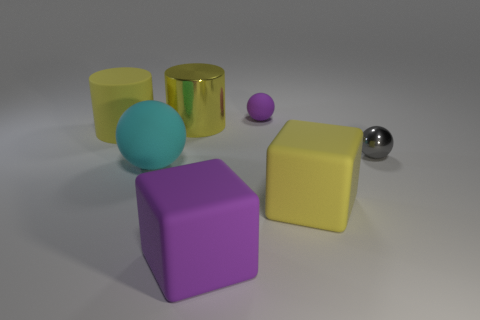Are there more small balls than large cyan cubes?
Your response must be concise. Yes. There is a large yellow matte thing that is behind the yellow cube; is it the same shape as the large yellow metallic thing?
Your answer should be very brief. Yes. Is the number of tiny gray balls less than the number of big blue things?
Provide a succinct answer. No. There is a sphere that is the same size as the yellow matte cylinder; what is its material?
Provide a short and direct response. Rubber. There is a rubber cylinder; does it have the same color as the cube that is behind the big purple matte thing?
Your response must be concise. Yes. Is the number of large cylinders that are right of the small purple rubber sphere less than the number of big cyan metal cylinders?
Your answer should be very brief. No. How many small matte spheres are there?
Your response must be concise. 1. What shape is the small object that is in front of the shiny object left of the tiny rubber ball?
Provide a succinct answer. Sphere. There is a small purple ball; what number of large things are behind it?
Offer a very short reply. 0. Is the material of the yellow cube the same as the cylinder that is behind the large yellow rubber cylinder?
Provide a succinct answer. No. 